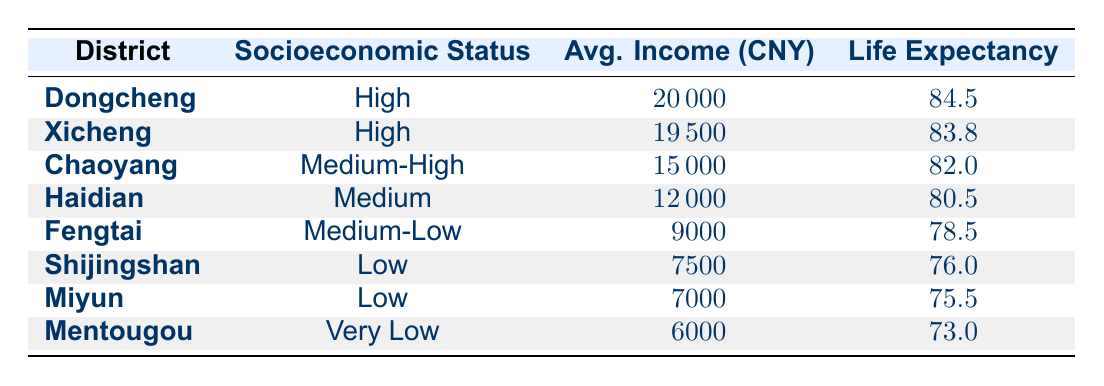What is the life expectancy in Dongcheng district? According to the table, the life expectancy in the Dongcheng district is directly listed as 84.5.
Answer: 84.5 What socioeconomic status does Fengtai district fall under? The table specifies the socioeconomic status of Fengtai district as Medium-Low.
Answer: Medium-Low Which district has the highest average income? The table shows that Dongcheng has the highest average income of 20000, which is higher than all other districts.
Answer: Dongcheng What is the life expectancy difference between Xicheng and Haidian? Life expectancy in Xicheng is 83.8, while in Haidian it is 80.5. The difference can be calculated as 83.8 - 80.5 = 3.3.
Answer: 3.3 Is the average income in Shijingshan higher than that in Miyun? By comparing the average incomes, Shijingshan has 7500 while Miyun has 7000. Since 7500 is greater than 7000, the statement is true.
Answer: Yes What is the average life expectancy of districts classified as Low? Districts classified as Low are Shijingshan (76.0) and Miyun (75.5). To find the average, we sum these two values: 76.0 + 75.5 = 151.5, then divide by 2, which gives us 151.5 / 2 = 75.75.
Answer: 75.75 Which socioeconomic status has the largest life expectancy and what is its value? The table indicates that the districts with the High socioeconomic status (Dongcheng and Xicheng) have life expectancies of 84.5 and 83.8 respectively. The highest is 84.5.
Answer: High, 84.5 Which district has the lowest average income and what is the value? Looking at the average income column, Mentougou has the lowest income at 6000, which is less than any other district.
Answer: 6000 How does the average life expectancy change as socioeconomic status decreases from High to Very Low? Reviewing the life expectancies, we notice a decrement: High (84.5), Medium-High (82.0), Medium (80.5), Medium-Low (78.5), Low (76.0), and Very Low (73.0). This shows a consistent decrease as socioeconomic status lowers.
Answer: Decreases consistently 